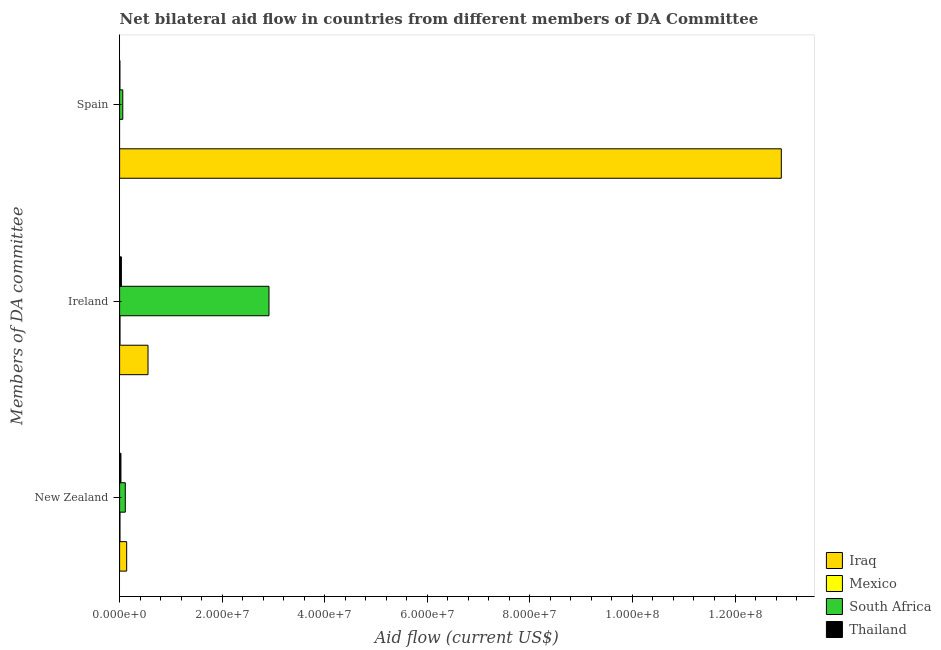Are the number of bars per tick equal to the number of legend labels?
Make the answer very short. No. Are the number of bars on each tick of the Y-axis equal?
Your answer should be compact. No. How many bars are there on the 2nd tick from the top?
Offer a terse response. 4. How many bars are there on the 1st tick from the bottom?
Keep it short and to the point. 4. What is the label of the 3rd group of bars from the top?
Give a very brief answer. New Zealand. What is the amount of aid provided by ireland in South Africa?
Your answer should be compact. 2.91e+07. Across all countries, what is the maximum amount of aid provided by spain?
Give a very brief answer. 1.29e+08. Across all countries, what is the minimum amount of aid provided by spain?
Provide a short and direct response. 0. In which country was the amount of aid provided by new zealand maximum?
Your answer should be compact. Iraq. What is the total amount of aid provided by new zealand in the graph?
Your response must be concise. 2.82e+06. What is the difference between the amount of aid provided by new zealand in Iraq and that in Mexico?
Make the answer very short. 1.31e+06. What is the difference between the amount of aid provided by new zealand in Mexico and the amount of aid provided by spain in Iraq?
Offer a terse response. -1.29e+08. What is the average amount of aid provided by new zealand per country?
Your answer should be compact. 7.05e+05. What is the difference between the amount of aid provided by new zealand and amount of aid provided by ireland in South Africa?
Ensure brevity in your answer.  -2.80e+07. In how many countries, is the amount of aid provided by spain greater than 32000000 US$?
Ensure brevity in your answer.  1. What is the ratio of the amount of aid provided by ireland in South Africa to that in Thailand?
Provide a succinct answer. 83.23. Is the amount of aid provided by new zealand in Thailand less than that in Iraq?
Your answer should be compact. Yes. What is the difference between the highest and the second highest amount of aid provided by spain?
Your answer should be compact. 1.28e+08. What is the difference between the highest and the lowest amount of aid provided by new zealand?
Your answer should be compact. 1.31e+06. Is it the case that in every country, the sum of the amount of aid provided by new zealand and amount of aid provided by ireland is greater than the amount of aid provided by spain?
Offer a terse response. No. How many bars are there?
Offer a very short reply. 11. What is the difference between two consecutive major ticks on the X-axis?
Your answer should be compact. 2.00e+07. Where does the legend appear in the graph?
Your answer should be very brief. Bottom right. How many legend labels are there?
Your answer should be compact. 4. How are the legend labels stacked?
Ensure brevity in your answer.  Vertical. What is the title of the graph?
Provide a succinct answer. Net bilateral aid flow in countries from different members of DA Committee. What is the label or title of the Y-axis?
Your answer should be very brief. Members of DA committee. What is the Aid flow (current US$) in Iraq in New Zealand?
Give a very brief answer. 1.38e+06. What is the Aid flow (current US$) of Mexico in New Zealand?
Your answer should be compact. 7.00e+04. What is the Aid flow (current US$) of South Africa in New Zealand?
Keep it short and to the point. 1.11e+06. What is the Aid flow (current US$) in Iraq in Ireland?
Provide a succinct answer. 5.54e+06. What is the Aid flow (current US$) in Mexico in Ireland?
Offer a very short reply. 8.00e+04. What is the Aid flow (current US$) of South Africa in Ireland?
Your answer should be very brief. 2.91e+07. What is the Aid flow (current US$) in Iraq in Spain?
Your response must be concise. 1.29e+08. What is the Aid flow (current US$) in Mexico in Spain?
Your answer should be very brief. 0. What is the Aid flow (current US$) of South Africa in Spain?
Offer a very short reply. 6.20e+05. What is the Aid flow (current US$) in Thailand in Spain?
Offer a very short reply. 6.00e+04. Across all Members of DA committee, what is the maximum Aid flow (current US$) of Iraq?
Keep it short and to the point. 1.29e+08. Across all Members of DA committee, what is the maximum Aid flow (current US$) in South Africa?
Give a very brief answer. 2.91e+07. Across all Members of DA committee, what is the maximum Aid flow (current US$) of Thailand?
Your response must be concise. 3.50e+05. Across all Members of DA committee, what is the minimum Aid flow (current US$) in Iraq?
Your answer should be compact. 1.38e+06. Across all Members of DA committee, what is the minimum Aid flow (current US$) of South Africa?
Your answer should be very brief. 6.20e+05. Across all Members of DA committee, what is the minimum Aid flow (current US$) of Thailand?
Keep it short and to the point. 6.00e+04. What is the total Aid flow (current US$) of Iraq in the graph?
Provide a short and direct response. 1.36e+08. What is the total Aid flow (current US$) of South Africa in the graph?
Keep it short and to the point. 3.09e+07. What is the total Aid flow (current US$) of Thailand in the graph?
Make the answer very short. 6.70e+05. What is the difference between the Aid flow (current US$) in Iraq in New Zealand and that in Ireland?
Your answer should be very brief. -4.16e+06. What is the difference between the Aid flow (current US$) in Mexico in New Zealand and that in Ireland?
Your answer should be compact. -10000. What is the difference between the Aid flow (current US$) in South Africa in New Zealand and that in Ireland?
Offer a terse response. -2.80e+07. What is the difference between the Aid flow (current US$) of Iraq in New Zealand and that in Spain?
Make the answer very short. -1.28e+08. What is the difference between the Aid flow (current US$) in Thailand in New Zealand and that in Spain?
Ensure brevity in your answer.  2.00e+05. What is the difference between the Aid flow (current US$) of Iraq in Ireland and that in Spain?
Provide a short and direct response. -1.23e+08. What is the difference between the Aid flow (current US$) of South Africa in Ireland and that in Spain?
Your answer should be very brief. 2.85e+07. What is the difference between the Aid flow (current US$) in Thailand in Ireland and that in Spain?
Provide a succinct answer. 2.90e+05. What is the difference between the Aid flow (current US$) of Iraq in New Zealand and the Aid flow (current US$) of Mexico in Ireland?
Provide a succinct answer. 1.30e+06. What is the difference between the Aid flow (current US$) in Iraq in New Zealand and the Aid flow (current US$) in South Africa in Ireland?
Provide a short and direct response. -2.78e+07. What is the difference between the Aid flow (current US$) in Iraq in New Zealand and the Aid flow (current US$) in Thailand in Ireland?
Your response must be concise. 1.03e+06. What is the difference between the Aid flow (current US$) in Mexico in New Zealand and the Aid flow (current US$) in South Africa in Ireland?
Your answer should be compact. -2.91e+07. What is the difference between the Aid flow (current US$) in Mexico in New Zealand and the Aid flow (current US$) in Thailand in Ireland?
Your answer should be very brief. -2.80e+05. What is the difference between the Aid flow (current US$) in South Africa in New Zealand and the Aid flow (current US$) in Thailand in Ireland?
Your answer should be very brief. 7.60e+05. What is the difference between the Aid flow (current US$) in Iraq in New Zealand and the Aid flow (current US$) in South Africa in Spain?
Provide a short and direct response. 7.60e+05. What is the difference between the Aid flow (current US$) in Iraq in New Zealand and the Aid flow (current US$) in Thailand in Spain?
Provide a succinct answer. 1.32e+06. What is the difference between the Aid flow (current US$) of Mexico in New Zealand and the Aid flow (current US$) of South Africa in Spain?
Make the answer very short. -5.50e+05. What is the difference between the Aid flow (current US$) of Mexico in New Zealand and the Aid flow (current US$) of Thailand in Spain?
Ensure brevity in your answer.  10000. What is the difference between the Aid flow (current US$) in South Africa in New Zealand and the Aid flow (current US$) in Thailand in Spain?
Your response must be concise. 1.05e+06. What is the difference between the Aid flow (current US$) of Iraq in Ireland and the Aid flow (current US$) of South Africa in Spain?
Keep it short and to the point. 4.92e+06. What is the difference between the Aid flow (current US$) in Iraq in Ireland and the Aid flow (current US$) in Thailand in Spain?
Provide a short and direct response. 5.48e+06. What is the difference between the Aid flow (current US$) in Mexico in Ireland and the Aid flow (current US$) in South Africa in Spain?
Provide a succinct answer. -5.40e+05. What is the difference between the Aid flow (current US$) of South Africa in Ireland and the Aid flow (current US$) of Thailand in Spain?
Your response must be concise. 2.91e+07. What is the average Aid flow (current US$) of Iraq per Members of DA committee?
Offer a very short reply. 4.53e+07. What is the average Aid flow (current US$) of South Africa per Members of DA committee?
Make the answer very short. 1.03e+07. What is the average Aid flow (current US$) in Thailand per Members of DA committee?
Your answer should be compact. 2.23e+05. What is the difference between the Aid flow (current US$) in Iraq and Aid flow (current US$) in Mexico in New Zealand?
Provide a short and direct response. 1.31e+06. What is the difference between the Aid flow (current US$) of Iraq and Aid flow (current US$) of South Africa in New Zealand?
Keep it short and to the point. 2.70e+05. What is the difference between the Aid flow (current US$) of Iraq and Aid flow (current US$) of Thailand in New Zealand?
Offer a very short reply. 1.12e+06. What is the difference between the Aid flow (current US$) in Mexico and Aid flow (current US$) in South Africa in New Zealand?
Offer a very short reply. -1.04e+06. What is the difference between the Aid flow (current US$) of South Africa and Aid flow (current US$) of Thailand in New Zealand?
Give a very brief answer. 8.50e+05. What is the difference between the Aid flow (current US$) in Iraq and Aid flow (current US$) in Mexico in Ireland?
Offer a terse response. 5.46e+06. What is the difference between the Aid flow (current US$) in Iraq and Aid flow (current US$) in South Africa in Ireland?
Provide a short and direct response. -2.36e+07. What is the difference between the Aid flow (current US$) of Iraq and Aid flow (current US$) of Thailand in Ireland?
Offer a very short reply. 5.19e+06. What is the difference between the Aid flow (current US$) in Mexico and Aid flow (current US$) in South Africa in Ireland?
Ensure brevity in your answer.  -2.90e+07. What is the difference between the Aid flow (current US$) in South Africa and Aid flow (current US$) in Thailand in Ireland?
Provide a short and direct response. 2.88e+07. What is the difference between the Aid flow (current US$) of Iraq and Aid flow (current US$) of South Africa in Spain?
Give a very brief answer. 1.28e+08. What is the difference between the Aid flow (current US$) of Iraq and Aid flow (current US$) of Thailand in Spain?
Your answer should be very brief. 1.29e+08. What is the difference between the Aid flow (current US$) of South Africa and Aid flow (current US$) of Thailand in Spain?
Offer a very short reply. 5.60e+05. What is the ratio of the Aid flow (current US$) in Iraq in New Zealand to that in Ireland?
Your answer should be compact. 0.25. What is the ratio of the Aid flow (current US$) in South Africa in New Zealand to that in Ireland?
Your answer should be compact. 0.04. What is the ratio of the Aid flow (current US$) of Thailand in New Zealand to that in Ireland?
Your response must be concise. 0.74. What is the ratio of the Aid flow (current US$) in Iraq in New Zealand to that in Spain?
Provide a short and direct response. 0.01. What is the ratio of the Aid flow (current US$) of South Africa in New Zealand to that in Spain?
Provide a succinct answer. 1.79. What is the ratio of the Aid flow (current US$) of Thailand in New Zealand to that in Spain?
Your answer should be compact. 4.33. What is the ratio of the Aid flow (current US$) of Iraq in Ireland to that in Spain?
Provide a succinct answer. 0.04. What is the ratio of the Aid flow (current US$) of South Africa in Ireland to that in Spain?
Your answer should be very brief. 46.98. What is the ratio of the Aid flow (current US$) in Thailand in Ireland to that in Spain?
Your answer should be compact. 5.83. What is the difference between the highest and the second highest Aid flow (current US$) of Iraq?
Your answer should be very brief. 1.23e+08. What is the difference between the highest and the second highest Aid flow (current US$) in South Africa?
Your answer should be compact. 2.80e+07. What is the difference between the highest and the lowest Aid flow (current US$) of Iraq?
Make the answer very short. 1.28e+08. What is the difference between the highest and the lowest Aid flow (current US$) in South Africa?
Offer a very short reply. 2.85e+07. What is the difference between the highest and the lowest Aid flow (current US$) of Thailand?
Provide a succinct answer. 2.90e+05. 